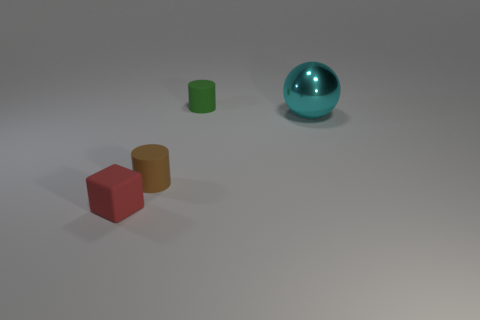Add 1 gray things. How many objects exist? 5 Subtract all cubes. How many objects are left? 3 Add 2 blue spheres. How many blue spheres exist? 2 Subtract 0 yellow cubes. How many objects are left? 4 Subtract all tiny objects. Subtract all brown matte things. How many objects are left? 0 Add 1 green cylinders. How many green cylinders are left? 2 